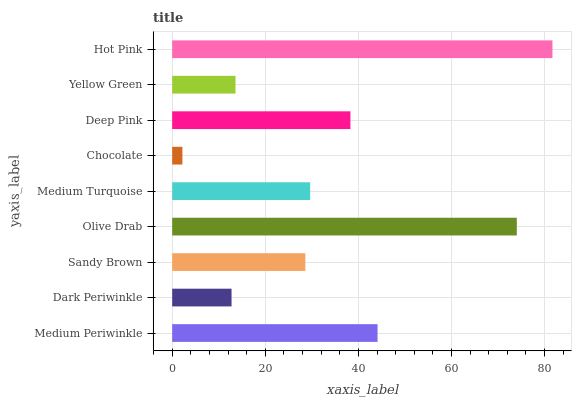Is Chocolate the minimum?
Answer yes or no. Yes. Is Hot Pink the maximum?
Answer yes or no. Yes. Is Dark Periwinkle the minimum?
Answer yes or no. No. Is Dark Periwinkle the maximum?
Answer yes or no. No. Is Medium Periwinkle greater than Dark Periwinkle?
Answer yes or no. Yes. Is Dark Periwinkle less than Medium Periwinkle?
Answer yes or no. Yes. Is Dark Periwinkle greater than Medium Periwinkle?
Answer yes or no. No. Is Medium Periwinkle less than Dark Periwinkle?
Answer yes or no. No. Is Medium Turquoise the high median?
Answer yes or no. Yes. Is Medium Turquoise the low median?
Answer yes or no. Yes. Is Medium Periwinkle the high median?
Answer yes or no. No. Is Hot Pink the low median?
Answer yes or no. No. 